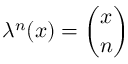<formula> <loc_0><loc_0><loc_500><loc_500>\lambda ^ { n } ( x ) = { \binom { x } { n } }</formula> 